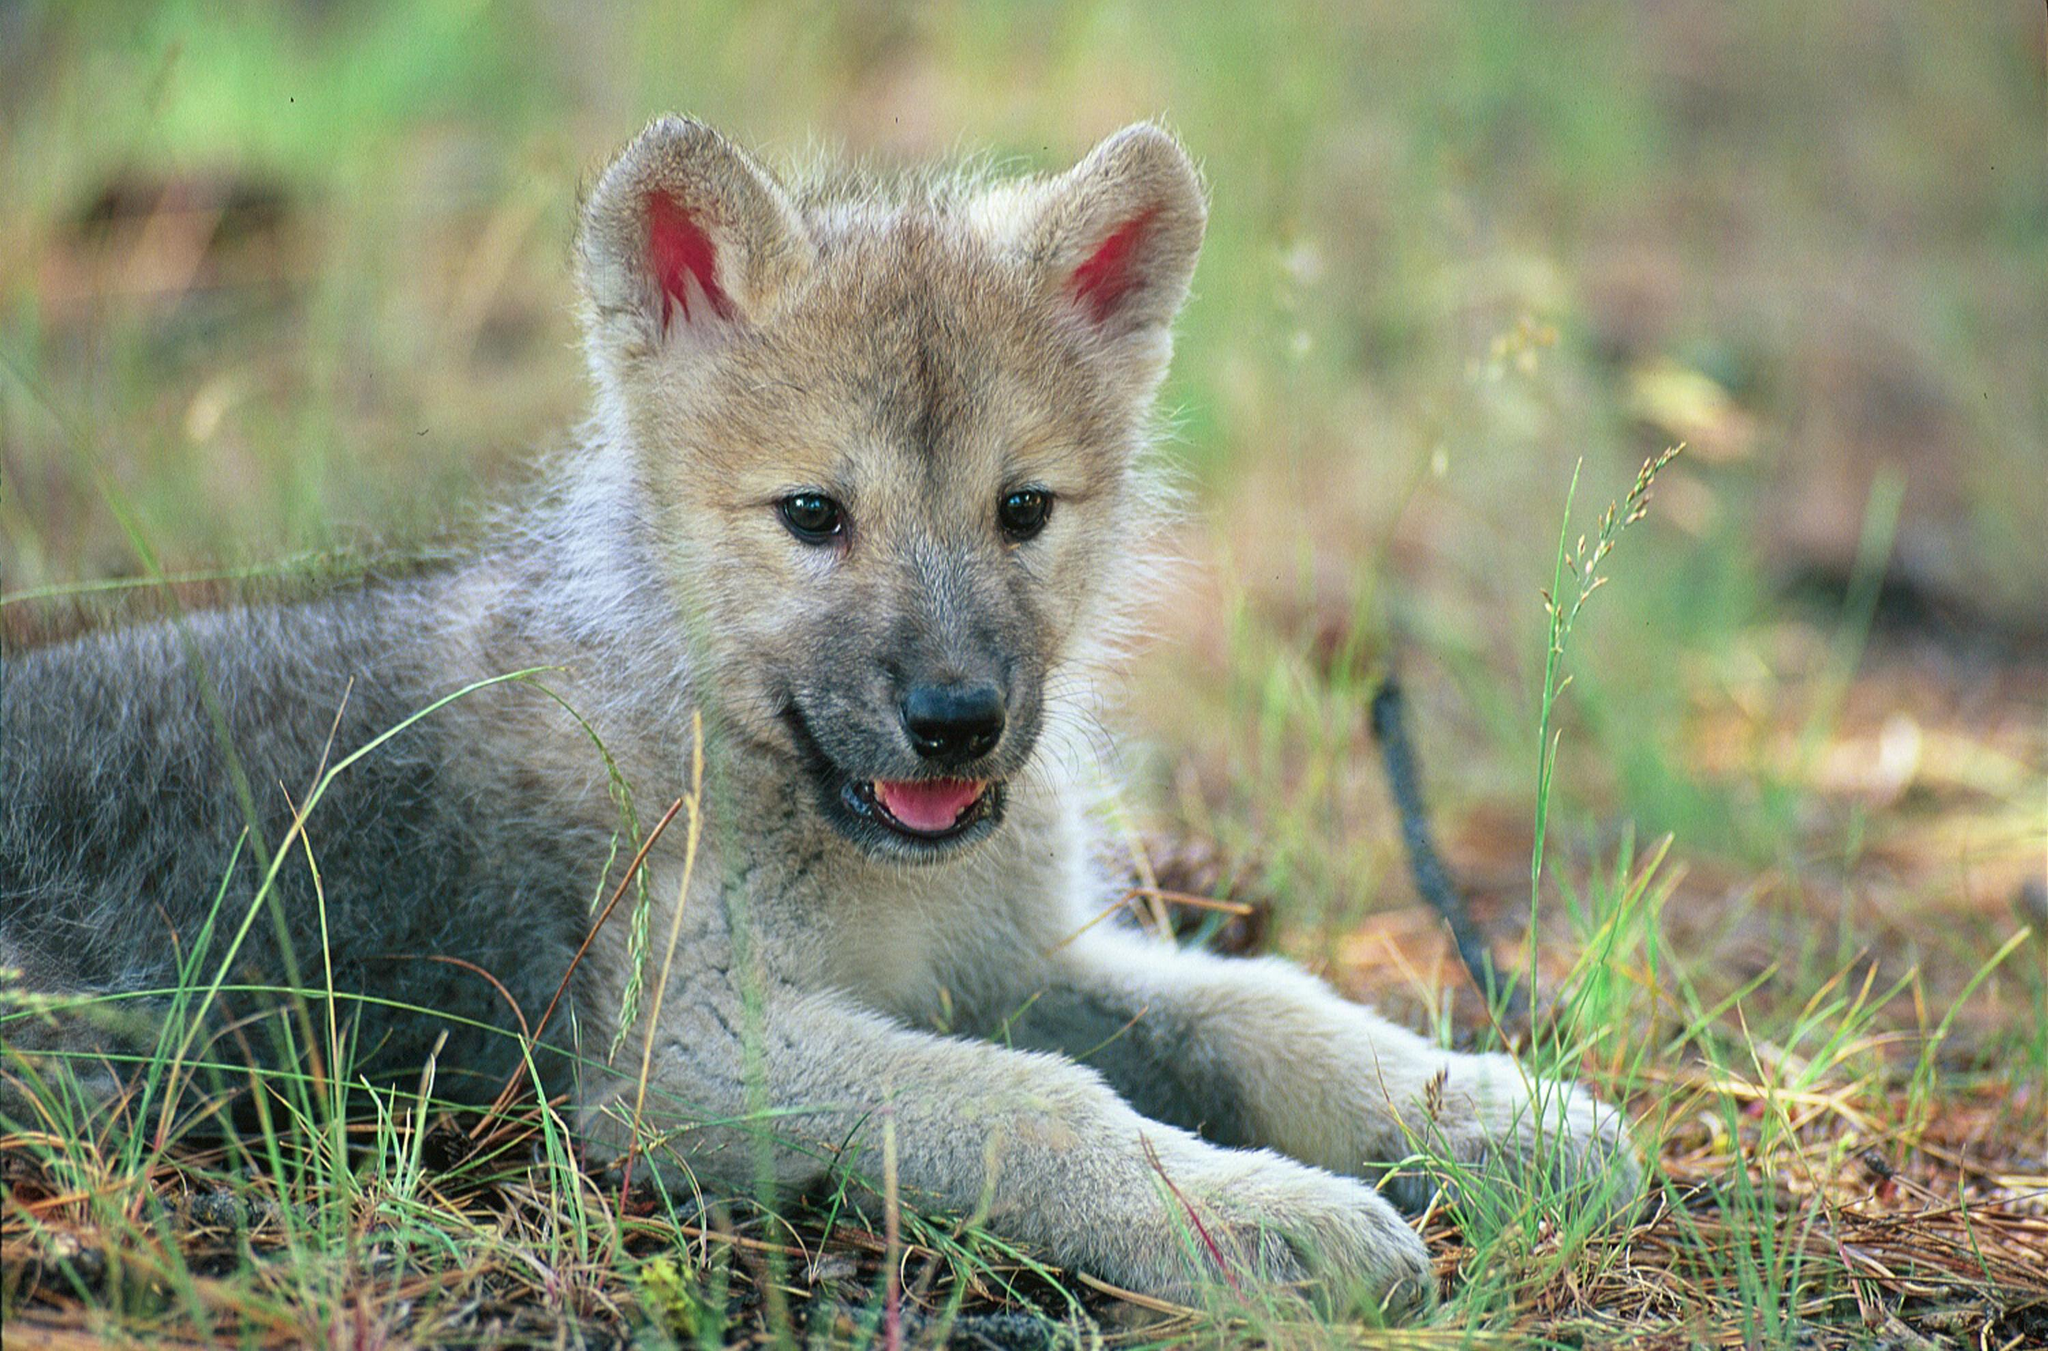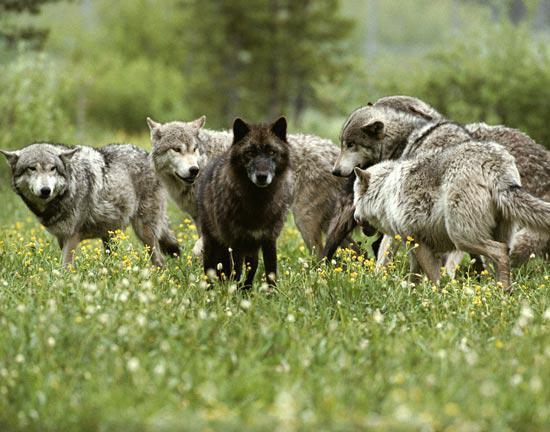The first image is the image on the left, the second image is the image on the right. Given the left and right images, does the statement "There is at least three wolves." hold true? Answer yes or no. Yes. The first image is the image on the left, the second image is the image on the right. Assess this claim about the two images: "In one of the images, there are two young wolves.". Correct or not? Answer yes or no. No. 